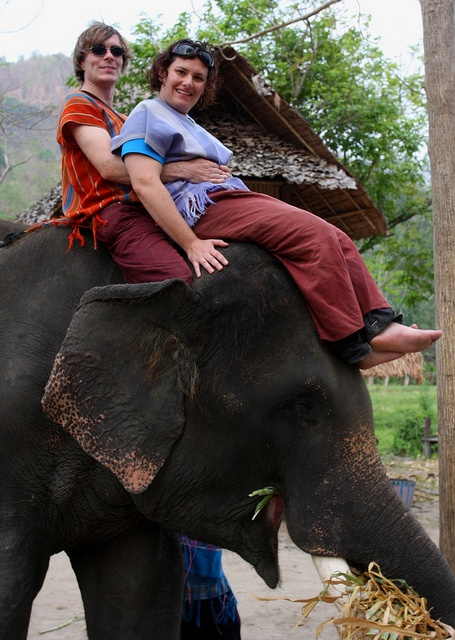Describe the objects in this image and their specific colors. I can see elephant in white, black, gray, and maroon tones, people in white, maroon, brown, black, and lightpink tones, people in white, maroon, black, and brown tones, and people in white, black, navy, blue, and darkblue tones in this image. 